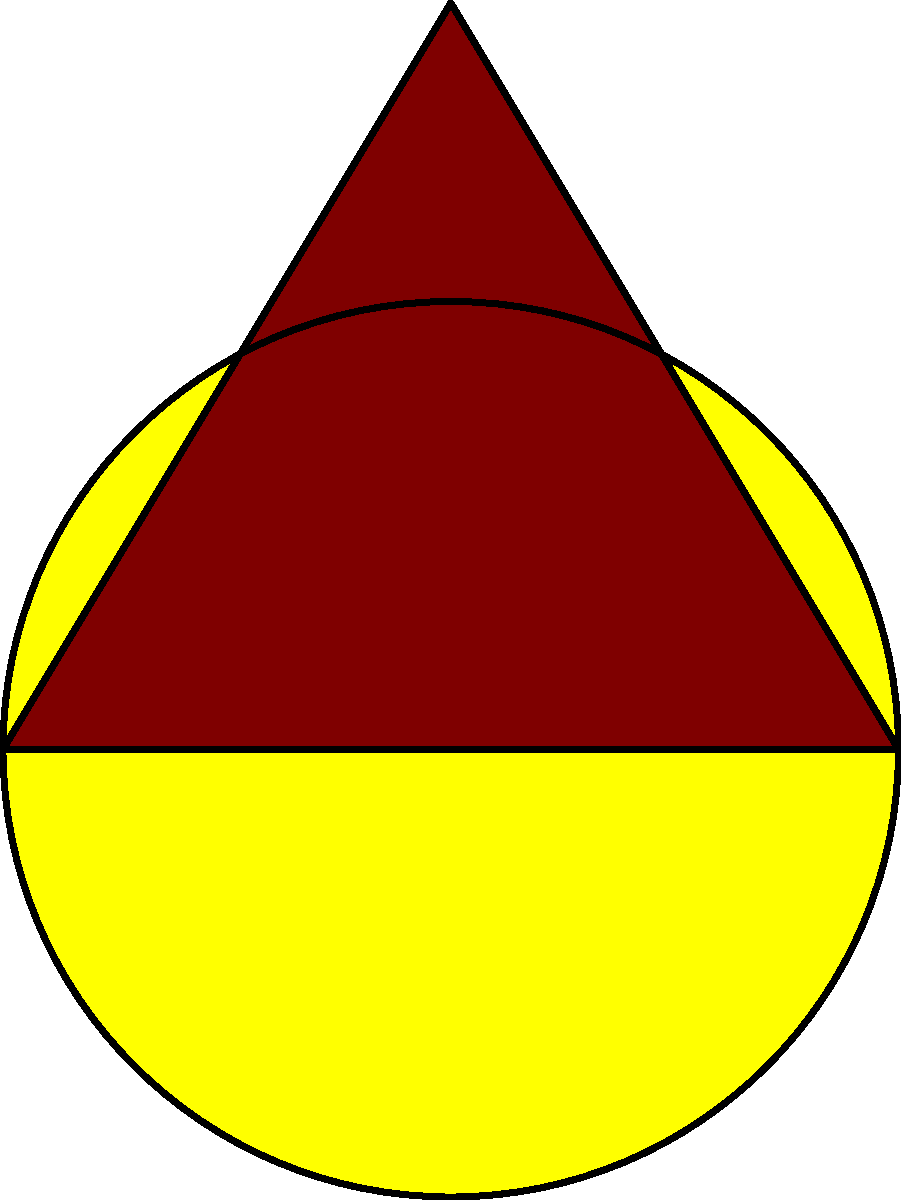Which Viking shield shape most closely resembles the relative size difference between the Sun and Earth when compared to celestial objects? To answer this question, let's analyze the shapes and size differences:

1. Viking shields:
   a. Round shield: Circular shape
   b. Kite shield: Elongated, pointed shape

2. Celestial objects:
   a. Sun: Much larger than Earth (about 109 times Earth's diameter)
   b. Earth: Significantly smaller than the Sun, but larger than the Moon
   c. Moon: Smallest of the three objects

3. Comparing ratios:
   a. Sun to Earth ratio: Approximately 109:1
   b. Round shield to kite shield ratio: The round shield is wider but shorter than the kite shield

4. Analysis:
   The round shield's circular shape and larger area compared to the kite shield better represents the significant size difference between the Sun and Earth.

5. Conclusion:
   The round shield's shape and size relative to the kite shield more closely resembles the Sun-Earth size relationship than the kite shield does.
Answer: Round shield 